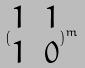Convert formula to latex. <formula><loc_0><loc_0><loc_500><loc_500>( \begin{matrix} 1 & 1 \\ 1 & 0 \end{matrix} ) ^ { m }</formula> 